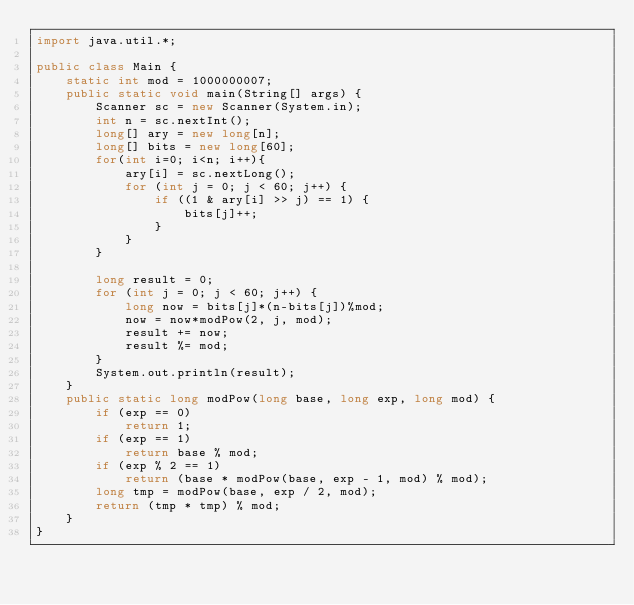<code> <loc_0><loc_0><loc_500><loc_500><_Java_>import java.util.*;

public class Main {
	static int mod = 1000000007;
	public static void main(String[] args) {
		Scanner sc = new Scanner(System.in);
		int n = sc.nextInt();
		long[] ary = new long[n];
		long[] bits = new long[60];
		for(int i=0; i<n; i++){
			ary[i] = sc.nextLong();
			for (int j = 0; j < 60; j++) {
				if ((1 & ary[i] >> j) == 1) {
					bits[j]++;
				}
			}
		}

		long result = 0;
		for (int j = 0; j < 60; j++) {
			long now = bits[j]*(n-bits[j])%mod;
			now = now*modPow(2, j, mod);
			result += now;
			result %= mod;
		}
		System.out.println(result);
	}
	public static long modPow(long base, long exp, long mod) {
		if (exp == 0)
			return 1;
		if (exp == 1)
			return base % mod;
		if (exp % 2 == 1)
			return (base * modPow(base, exp - 1, mod) % mod);
		long tmp = modPow(base, exp / 2, mod);
		return (tmp * tmp) % mod;
	}
}
</code> 